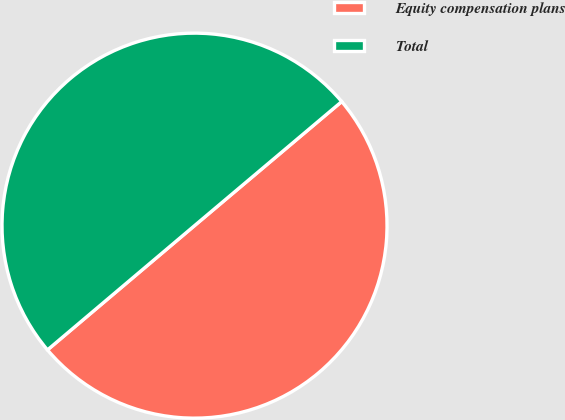<chart> <loc_0><loc_0><loc_500><loc_500><pie_chart><fcel>Equity compensation plans<fcel>Total<nl><fcel>49.98%<fcel>50.02%<nl></chart> 